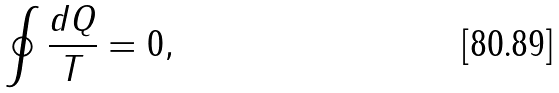<formula> <loc_0><loc_0><loc_500><loc_500>\oint \frac { d Q } { T } = 0 ,</formula> 